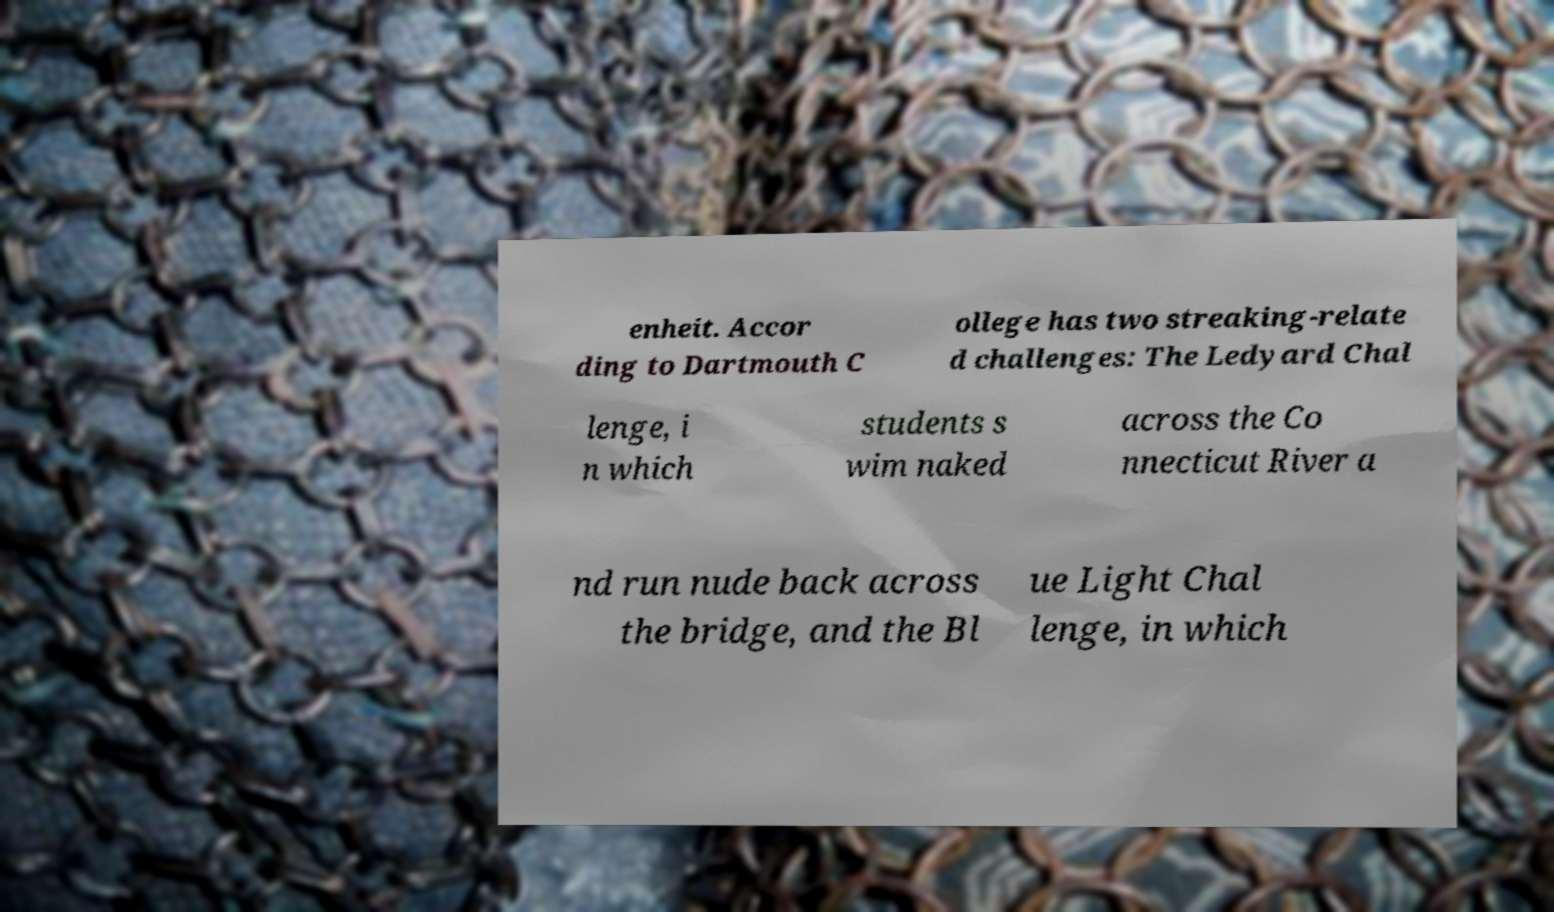Could you assist in decoding the text presented in this image and type it out clearly? enheit. Accor ding to Dartmouth C ollege has two streaking-relate d challenges: The Ledyard Chal lenge, i n which students s wim naked across the Co nnecticut River a nd run nude back across the bridge, and the Bl ue Light Chal lenge, in which 